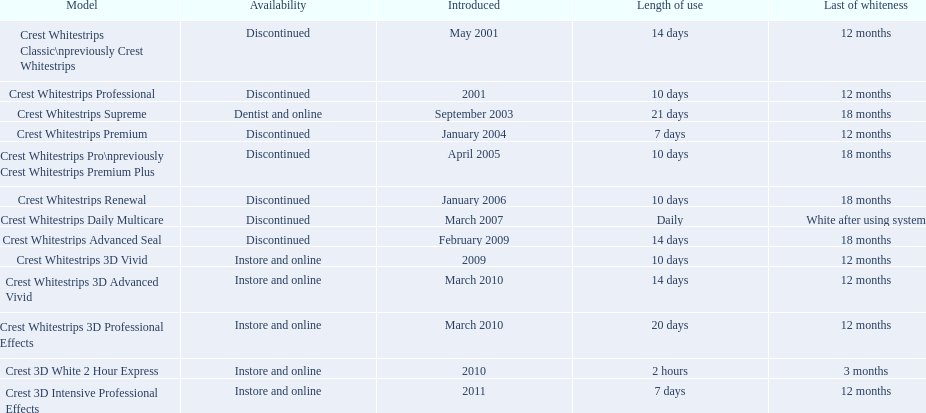What are the names of all the models? Crest Whitestrips Classic\npreviously Crest Whitestrips, Crest Whitestrips Professional, Crest Whitestrips Supreme, Crest Whitestrips Premium, Crest Whitestrips Pro\npreviously Crest Whitestrips Premium Plus, Crest Whitestrips Renewal, Crest Whitestrips Daily Multicare, Crest Whitestrips Advanced Seal, Crest Whitestrips 3D Vivid, Crest Whitestrips 3D Advanced Vivid, Crest Whitestrips 3D Professional Effects, Crest 3D White 2 Hour Express, Crest 3D Intensive Professional Effects. When did they first appear? May 2001, 2001, September 2003, January 2004, April 2005, January 2006, March 2007, February 2009, 2009, March 2010, March 2010, 2010, 2011. Besides crest whitestrips 3d advanced vivid, which other version was launched in march 2010? Crest Whitestrips 3D Professional Effects. 